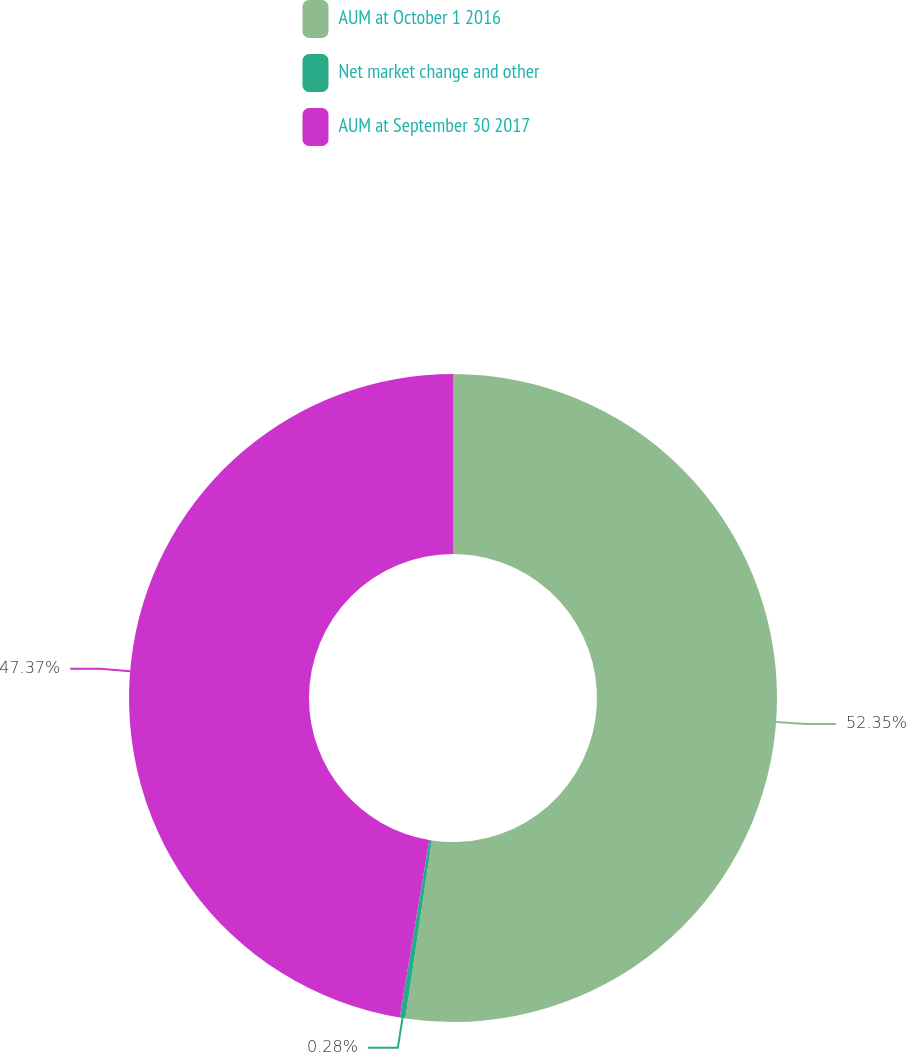<chart> <loc_0><loc_0><loc_500><loc_500><pie_chart><fcel>AUM at October 1 2016<fcel>Net market change and other<fcel>AUM at September 30 2017<nl><fcel>52.35%<fcel>0.28%<fcel>47.37%<nl></chart> 